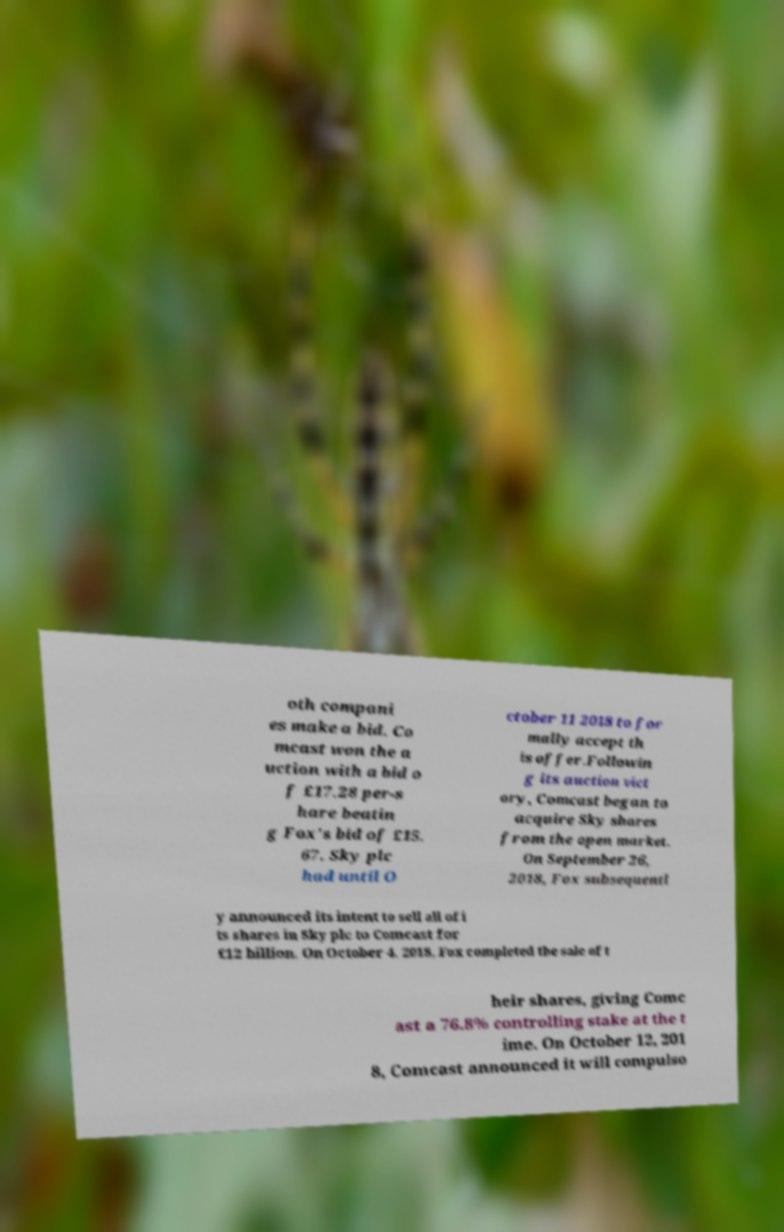Could you assist in decoding the text presented in this image and type it out clearly? oth compani es make a bid. Co mcast won the a uction with a bid o f £17.28 per-s hare beatin g Fox's bid of £15. 67. Sky plc had until O ctober 11 2018 to for mally accept th is offer.Followin g its auction vict ory, Comcast began to acquire Sky shares from the open market. On September 26, 2018, Fox subsequentl y announced its intent to sell all of i ts shares in Sky plc to Comcast for £12 billion. On October 4. 2018, Fox completed the sale of t heir shares, giving Comc ast a 76.8% controlling stake at the t ime. On October 12, 201 8, Comcast announced it will compulso 